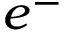<formula> <loc_0><loc_0><loc_500><loc_500>e ^ { - }</formula> 